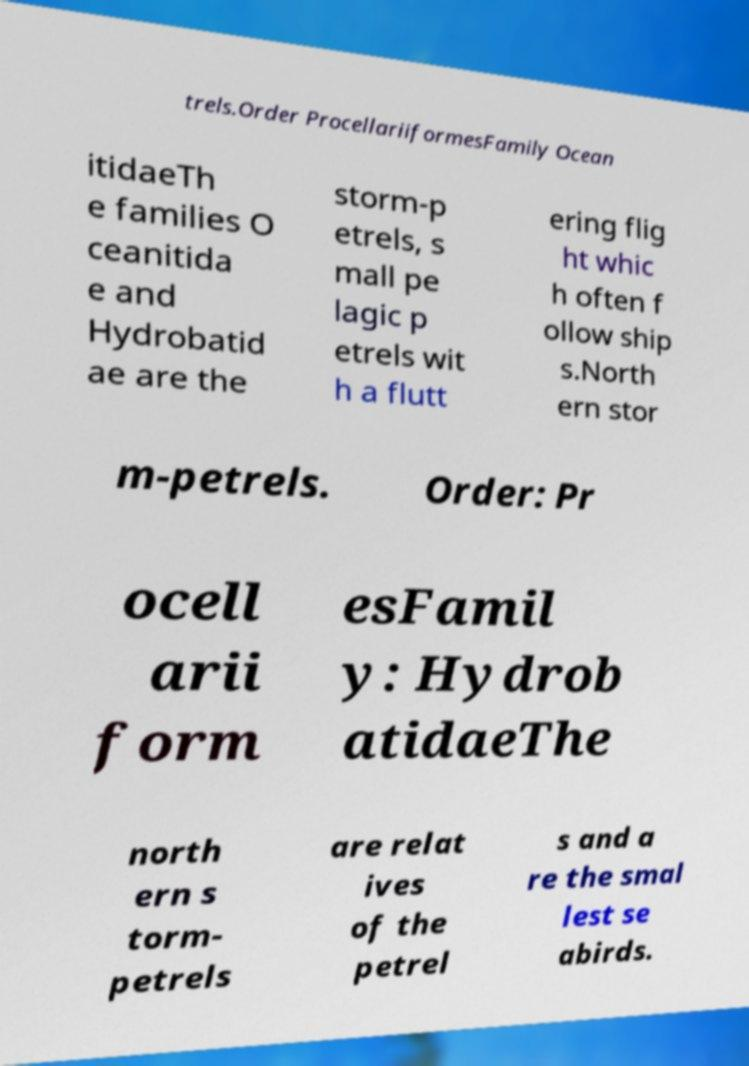Could you extract and type out the text from this image? trels.Order ProcellariiformesFamily Ocean itidaeTh e families O ceanitida e and Hydrobatid ae are the storm-p etrels, s mall pe lagic p etrels wit h a flutt ering flig ht whic h often f ollow ship s.North ern stor m-petrels. Order: Pr ocell arii form esFamil y: Hydrob atidaeThe north ern s torm- petrels are relat ives of the petrel s and a re the smal lest se abirds. 